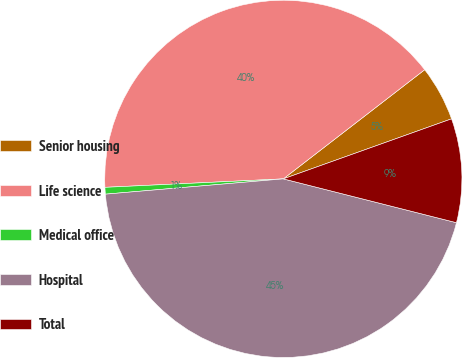<chart> <loc_0><loc_0><loc_500><loc_500><pie_chart><fcel>Senior housing<fcel>Life science<fcel>Medical office<fcel>Hospital<fcel>Total<nl><fcel>5.01%<fcel>40.29%<fcel>0.61%<fcel>44.69%<fcel>9.4%<nl></chart> 